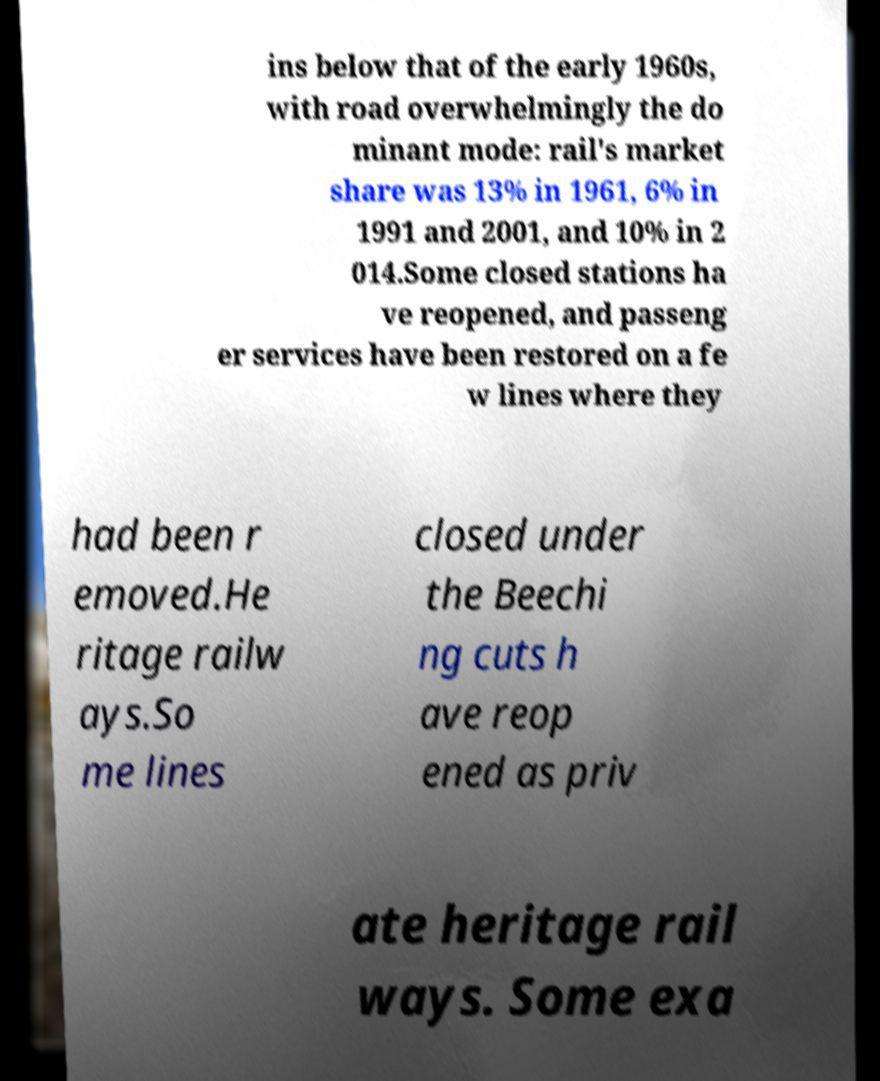Can you read and provide the text displayed in the image?This photo seems to have some interesting text. Can you extract and type it out for me? ins below that of the early 1960s, with road overwhelmingly the do minant mode: rail's market share was 13% in 1961, 6% in 1991 and 2001, and 10% in 2 014.Some closed stations ha ve reopened, and passeng er services have been restored on a fe w lines where they had been r emoved.He ritage railw ays.So me lines closed under the Beechi ng cuts h ave reop ened as priv ate heritage rail ways. Some exa 